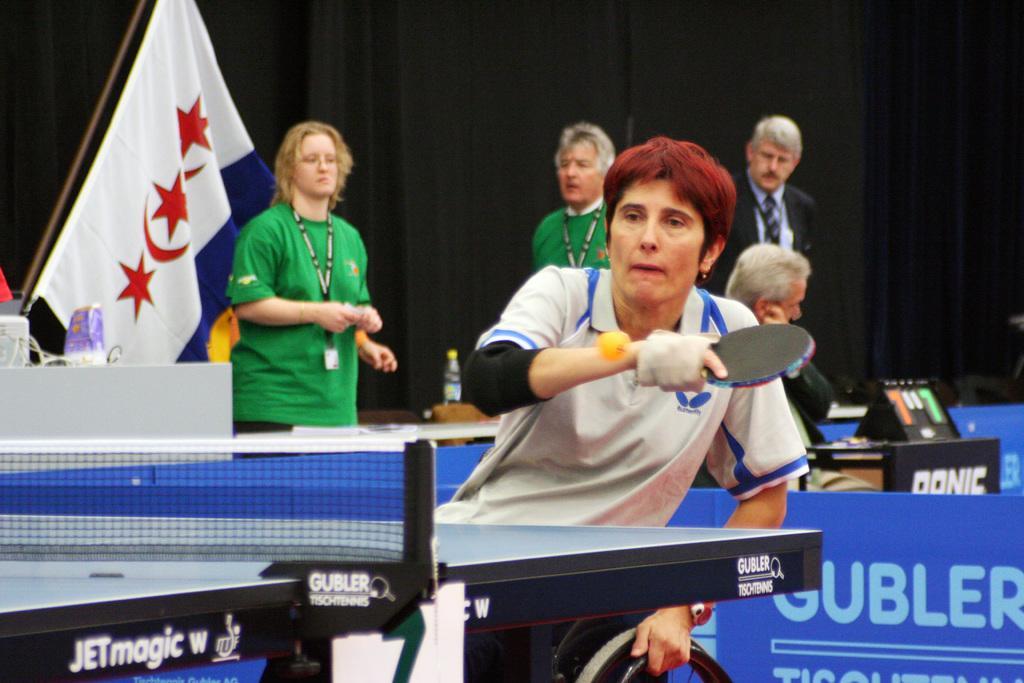How would you summarize this image in a sentence or two? In this picture I can see there is a man playing table tennis and in the backdrop I can see there are some other people and there is a flag and a black curtain. 